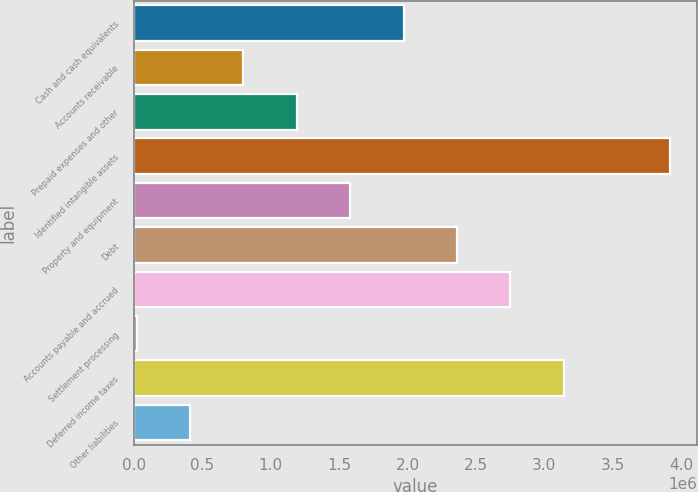<chart> <loc_0><loc_0><loc_500><loc_500><bar_chart><fcel>Cash and cash equivalents<fcel>Accounts receivable<fcel>Prepaid expenses and other<fcel>Identified intangible assets<fcel>Property and equipment<fcel>Debt<fcel>Accounts payable and accrued<fcel>Settlement processing<fcel>Deferred income taxes<fcel>Other liabilities<nl><fcel>1.9719e+06<fcel>801346<fcel>1.19153e+06<fcel>3.92282e+06<fcel>1.58171e+06<fcel>2.36208e+06<fcel>2.75227e+06<fcel>20978<fcel>3.14245e+06<fcel>411162<nl></chart> 